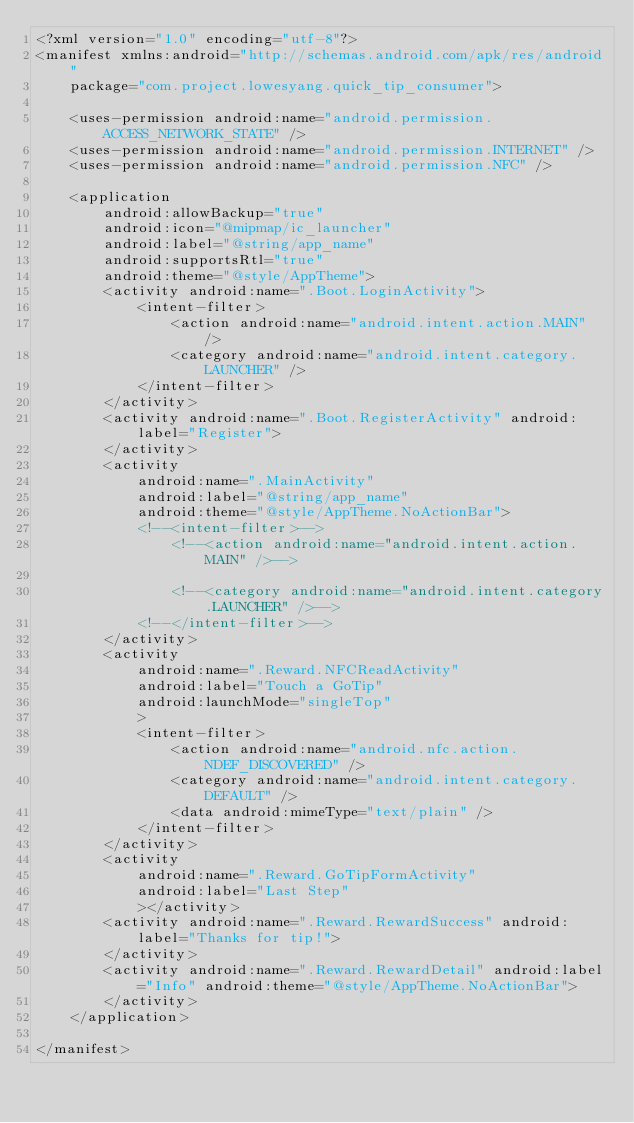<code> <loc_0><loc_0><loc_500><loc_500><_XML_><?xml version="1.0" encoding="utf-8"?>
<manifest xmlns:android="http://schemas.android.com/apk/res/android"
    package="com.project.lowesyang.quick_tip_consumer">

    <uses-permission android:name="android.permission.ACCESS_NETWORK_STATE" />
    <uses-permission android:name="android.permission.INTERNET" />
    <uses-permission android:name="android.permission.NFC" />

    <application
        android:allowBackup="true"
        android:icon="@mipmap/ic_launcher"
        android:label="@string/app_name"
        android:supportsRtl="true"
        android:theme="@style/AppTheme">
        <activity android:name=".Boot.LoginActivity">
            <intent-filter>
                <action android:name="android.intent.action.MAIN" />
                <category android:name="android.intent.category.LAUNCHER" />
            </intent-filter>
        </activity>
        <activity android:name=".Boot.RegisterActivity" android:label="Register">
        </activity>
        <activity
            android:name=".MainActivity"
            android:label="@string/app_name"
            android:theme="@style/AppTheme.NoActionBar">
            <!--<intent-filter>-->
                <!--<action android:name="android.intent.action.MAIN" />-->

                <!--<category android:name="android.intent.category.LAUNCHER" />-->
            <!--</intent-filter>-->
        </activity>
        <activity
            android:name=".Reward.NFCReadActivity"
            android:label="Touch a GoTip"
            android:launchMode="singleTop"
            >
            <intent-filter>
                <action android:name="android.nfc.action.NDEF_DISCOVERED" />
                <category android:name="android.intent.category.DEFAULT" />
                <data android:mimeType="text/plain" />
            </intent-filter>
        </activity>
        <activity
            android:name=".Reward.GoTipFormActivity"
            android:label="Last Step"
            ></activity>
        <activity android:name=".Reward.RewardSuccess" android:label="Thanks for tip!">
        </activity>
        <activity android:name=".Reward.RewardDetail" android:label="Info" android:theme="@style/AppTheme.NoActionBar">
        </activity>
    </application>

</manifest></code> 